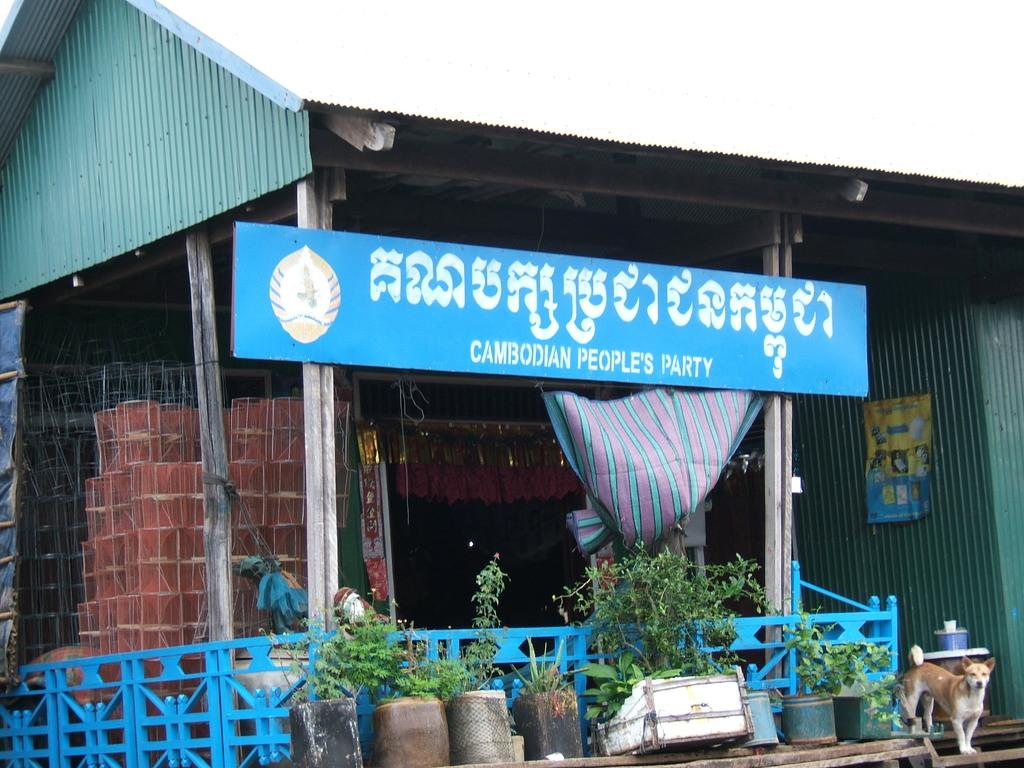What type of establishment is depicted in the image? The image appears to depict a shop. How can the shop be identified? There is a name board associated with the shop. What is in front of the shop? There is a fence and flower pots with plants in front of the shop. Is there any living creature present in the image? Yes, a dog is standing in front of the shop. What type of pollution can be seen in the image? There is no visible pollution in the image. Is there a playground associated with the shop in the image? There is no playground or any indication of play in the image. 